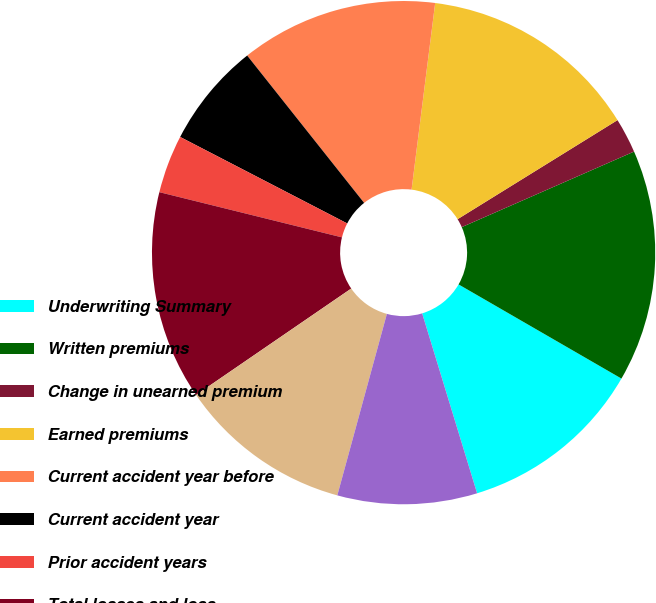Convert chart. <chart><loc_0><loc_0><loc_500><loc_500><pie_chart><fcel>Underwriting Summary<fcel>Written premiums<fcel>Change in unearned premium<fcel>Earned premiums<fcel>Current accident year before<fcel>Current accident year<fcel>Prior accident years<fcel>Total losses and loss<fcel>Amortization of deferred<fcel>Underwriting expenses<nl><fcel>11.94%<fcel>14.92%<fcel>2.25%<fcel>14.17%<fcel>12.68%<fcel>6.72%<fcel>3.74%<fcel>13.43%<fcel>11.19%<fcel>8.96%<nl></chart> 